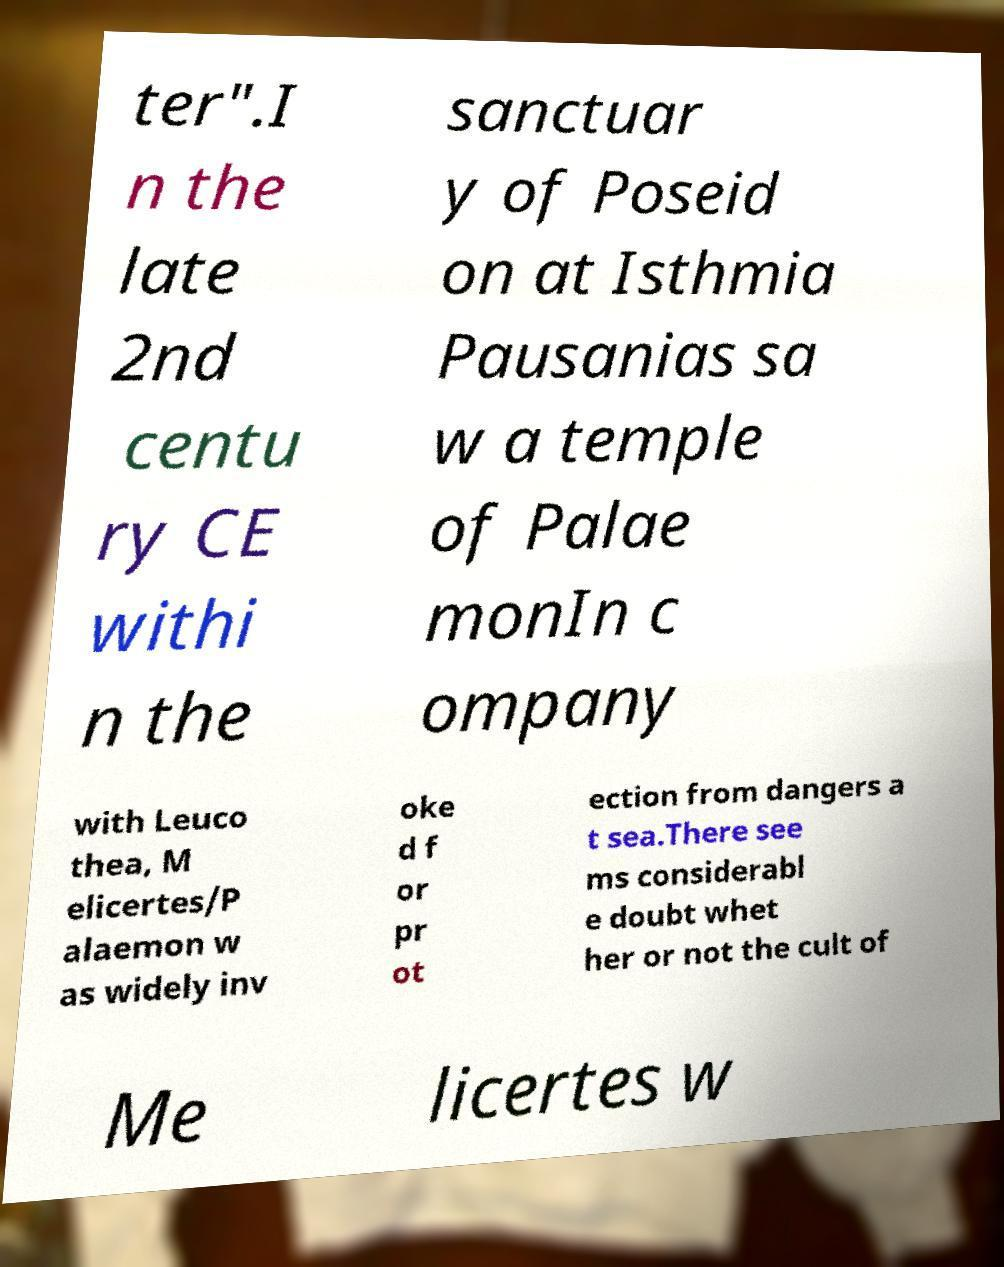What messages or text are displayed in this image? I need them in a readable, typed format. ter".I n the late 2nd centu ry CE withi n the sanctuar y of Poseid on at Isthmia Pausanias sa w a temple of Palae monIn c ompany with Leuco thea, M elicertes/P alaemon w as widely inv oke d f or pr ot ection from dangers a t sea.There see ms considerabl e doubt whet her or not the cult of Me licertes w 